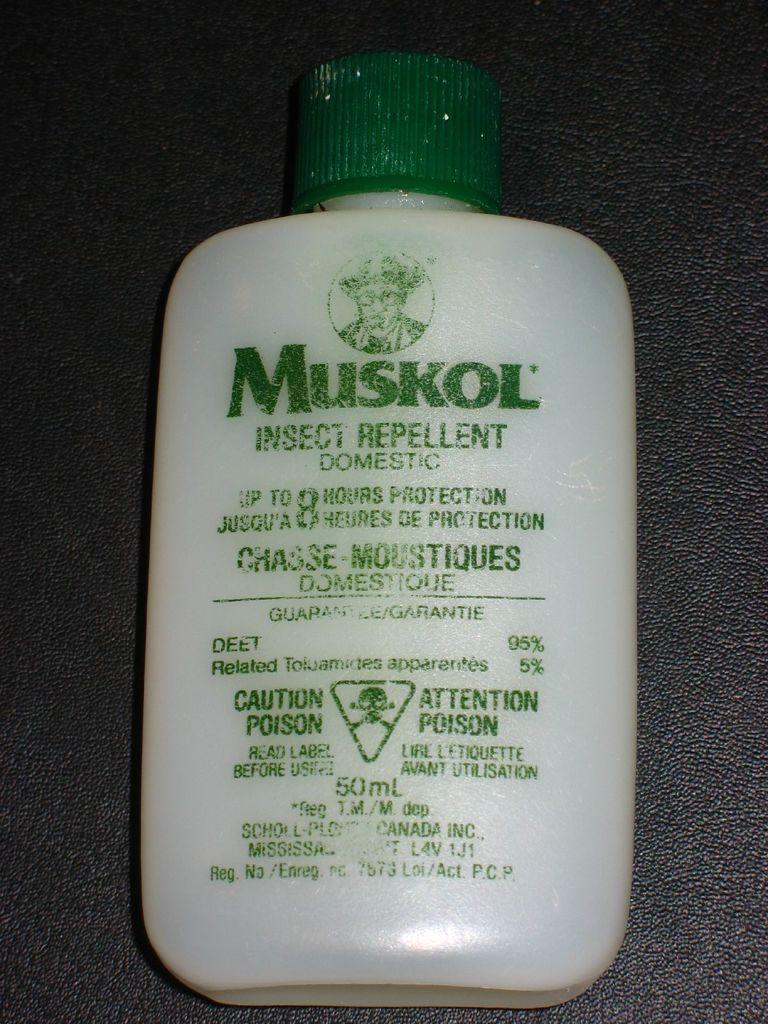What type of object is visible in the image? There is a plastic bottle in the image. What is written on the plastic bottle? The plastic bottle has the name "Muskol" on it. How many sticks are being used to cook the chicken in the image? There is no chicken or sticks present in the image; it only features a plastic bottle with the name "Muskol" on it. 